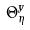Convert formula to latex. <formula><loc_0><loc_0><loc_500><loc_500>\Theta _ { \eta } ^ { y }</formula> 